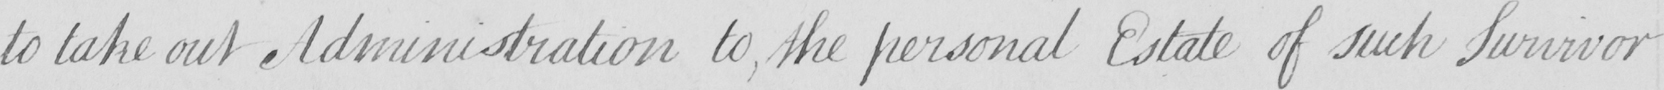Transcribe the text shown in this historical manuscript line. to take out Administration to , the personal Estate of such Survivor 